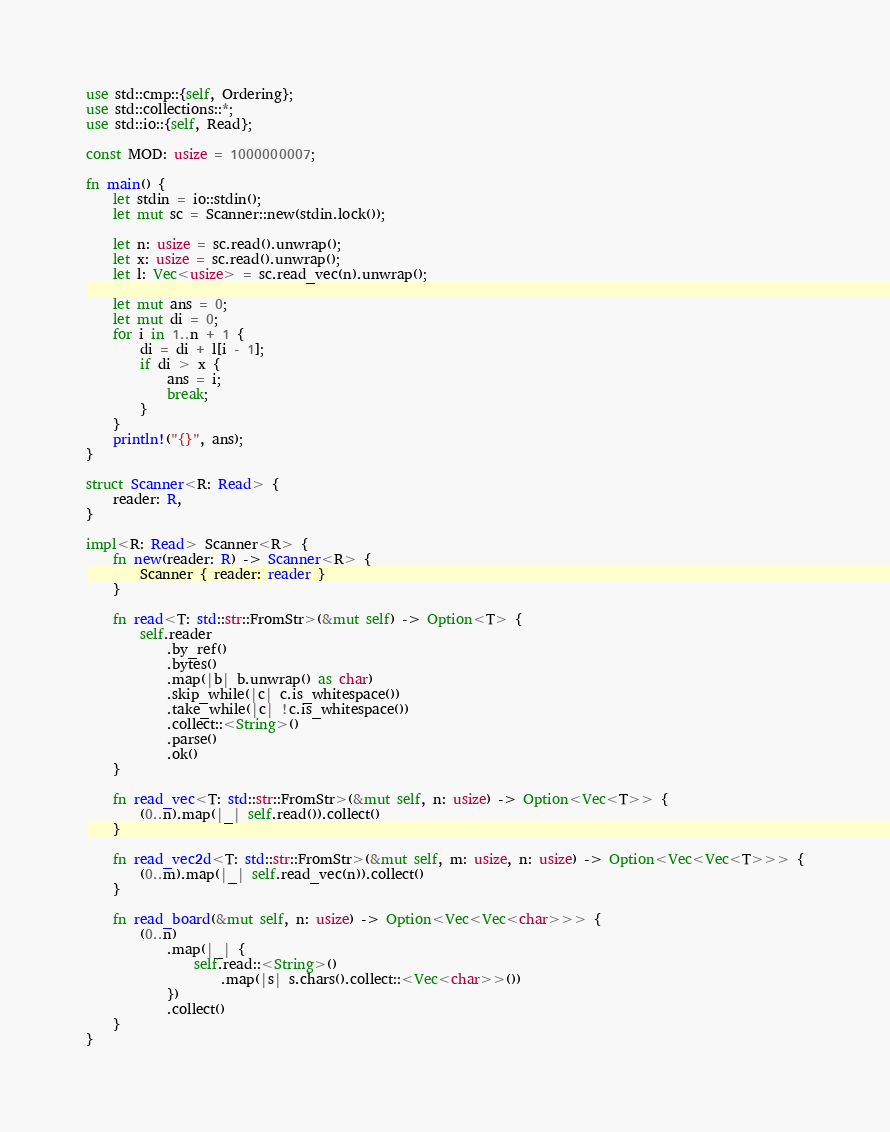Convert code to text. <code><loc_0><loc_0><loc_500><loc_500><_Rust_>use std::cmp::{self, Ordering};
use std::collections::*;
use std::io::{self, Read};

const MOD: usize = 1000000007;

fn main() {
    let stdin = io::stdin();
    let mut sc = Scanner::new(stdin.lock());

    let n: usize = sc.read().unwrap();
    let x: usize = sc.read().unwrap();
    let l: Vec<usize> = sc.read_vec(n).unwrap();

    let mut ans = 0;
    let mut di = 0;
    for i in 1..n + 1 {
        di = di + l[i - 1];
        if di > x {
            ans = i;
            break;
        }
    }
    println!("{}", ans);
}

struct Scanner<R: Read> {
    reader: R,
}

impl<R: Read> Scanner<R> {
    fn new(reader: R) -> Scanner<R> {
        Scanner { reader: reader }
    }

    fn read<T: std::str::FromStr>(&mut self) -> Option<T> {
        self.reader
            .by_ref()
            .bytes()
            .map(|b| b.unwrap() as char)
            .skip_while(|c| c.is_whitespace())
            .take_while(|c| !c.is_whitespace())
            .collect::<String>()
            .parse()
            .ok()
    }

    fn read_vec<T: std::str::FromStr>(&mut self, n: usize) -> Option<Vec<T>> {
        (0..n).map(|_| self.read()).collect()
    }

    fn read_vec2d<T: std::str::FromStr>(&mut self, m: usize, n: usize) -> Option<Vec<Vec<T>>> {
        (0..m).map(|_| self.read_vec(n)).collect()
    }

    fn read_board(&mut self, n: usize) -> Option<Vec<Vec<char>>> {
        (0..n)
            .map(|_| {
                self.read::<String>()
                    .map(|s| s.chars().collect::<Vec<char>>())
            })
            .collect()
    }
}
</code> 